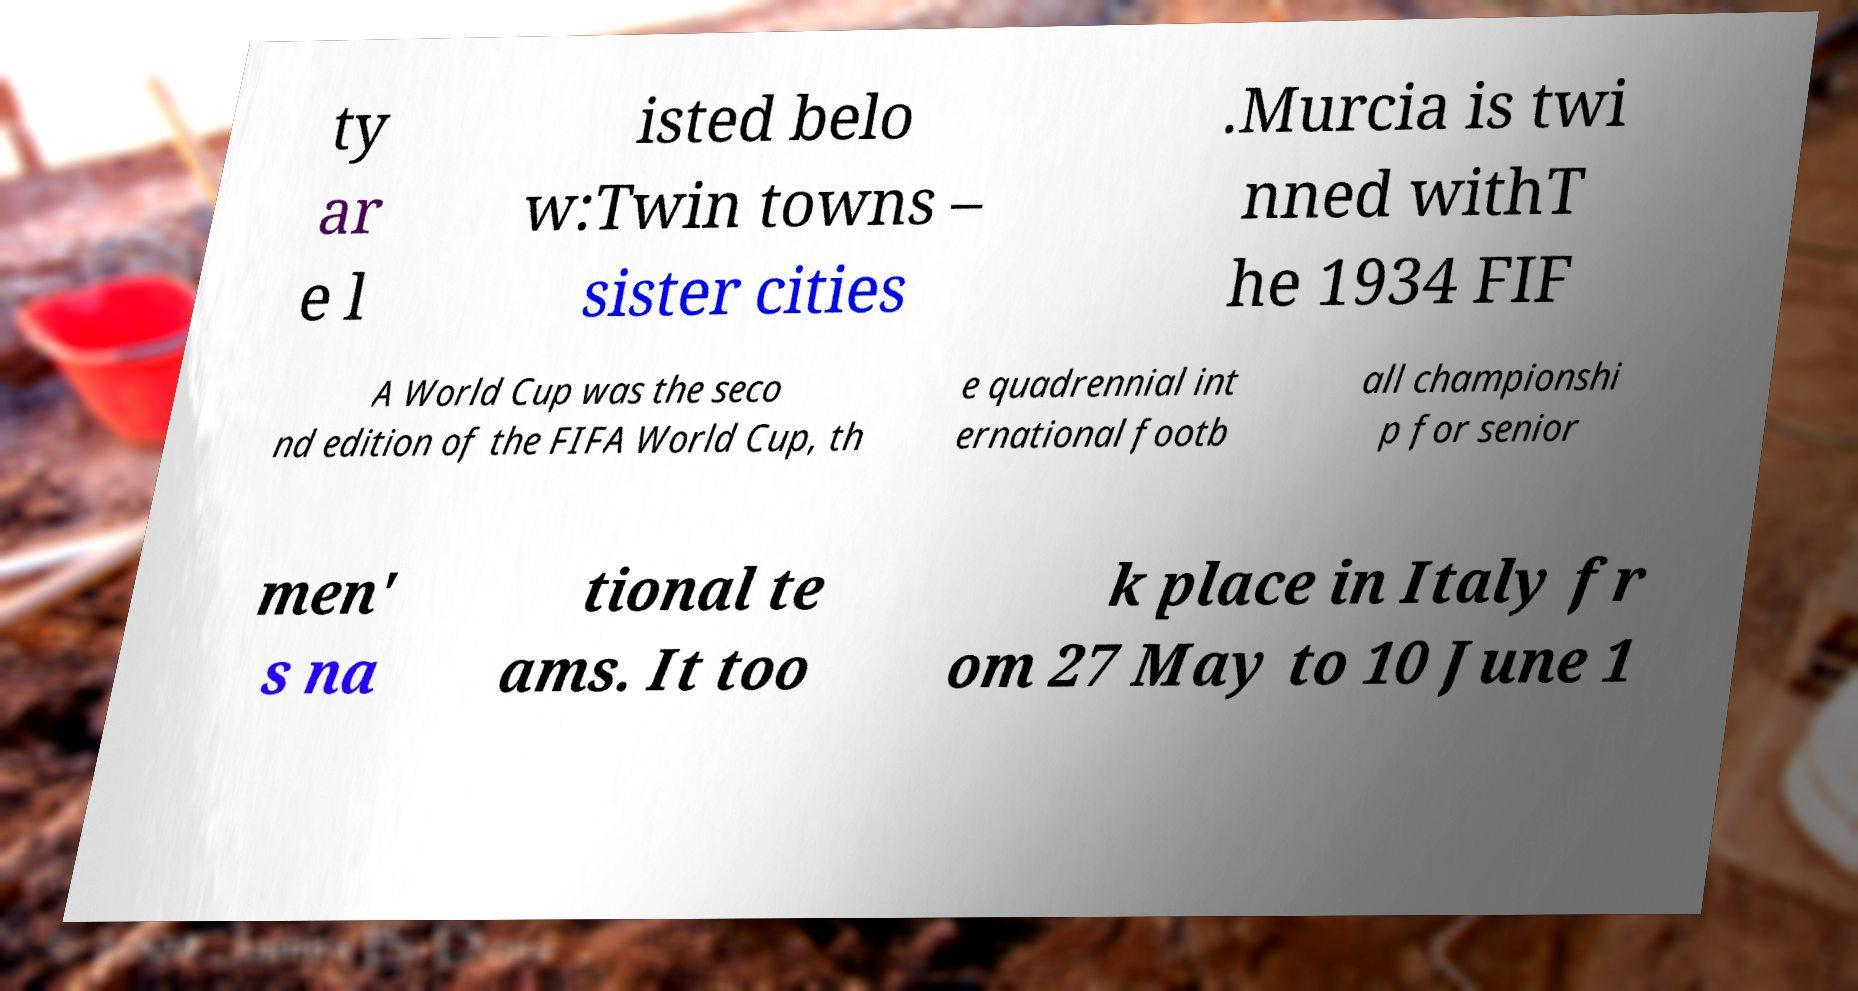Could you extract and type out the text from this image? ty ar e l isted belo w:Twin towns – sister cities .Murcia is twi nned withT he 1934 FIF A World Cup was the seco nd edition of the FIFA World Cup, th e quadrennial int ernational footb all championshi p for senior men' s na tional te ams. It too k place in Italy fr om 27 May to 10 June 1 